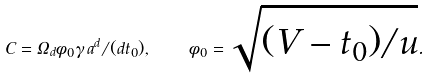Convert formula to latex. <formula><loc_0><loc_0><loc_500><loc_500>C = \Omega _ { d } \phi _ { 0 } \gamma \, a ^ { d } / ( d t _ { 0 } ) , \quad \phi _ { 0 } = \sqrt { ( V - t _ { 0 } ) / { u } } .</formula> 